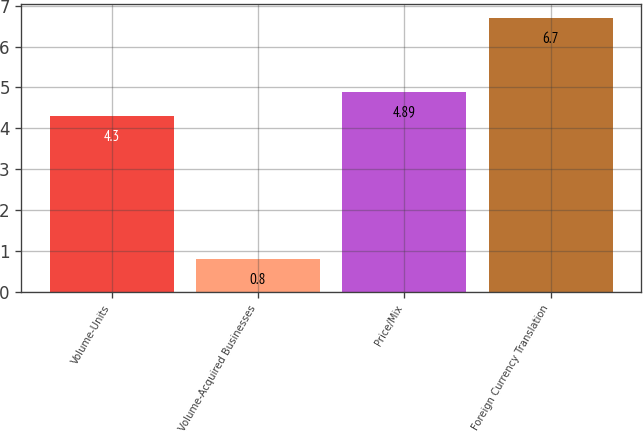Convert chart. <chart><loc_0><loc_0><loc_500><loc_500><bar_chart><fcel>Volume-Units<fcel>Volume-Acquired Businesses<fcel>Price/Mix<fcel>Foreign Currency Translation<nl><fcel>4.3<fcel>0.8<fcel>4.89<fcel>6.7<nl></chart> 